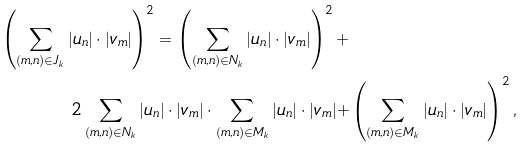Convert formula to latex. <formula><loc_0><loc_0><loc_500><loc_500>\left ( \sum _ { ( m , n ) \in J _ { k } } | u _ { n } | \cdot | v _ { m } | \right ) ^ { 2 } = \left ( \sum _ { ( m , n ) \in N _ { k } } | u _ { n } | \cdot | v _ { m } | \right ) ^ { 2 } + & \\ 2 \sum _ { ( m , n ) \in N _ { k } } | u _ { n } | \cdot | v _ { m } | \cdot \sum _ { ( m , n ) \in M _ { k } } | u _ { n } | \cdot | v _ { m } | + & \left ( \sum _ { ( m , n ) \in M _ { k } } | u _ { n } | \cdot | v _ { m } | \right ) ^ { 2 } ,</formula> 